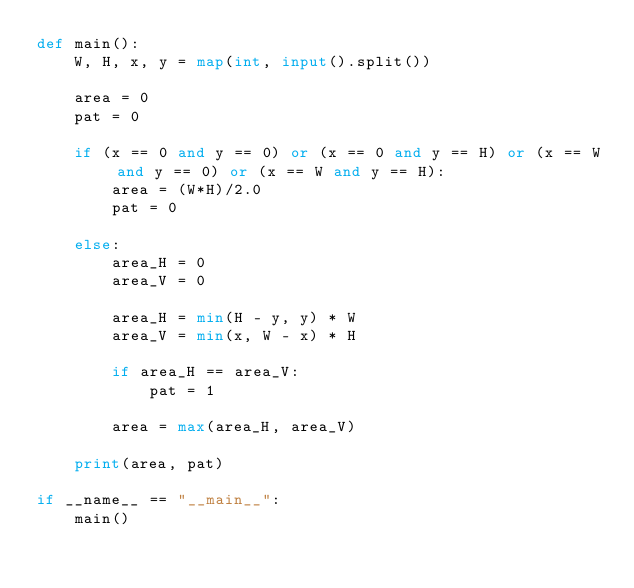Convert code to text. <code><loc_0><loc_0><loc_500><loc_500><_Python_>def main():
    W, H, x, y = map(int, input().split())

    area = 0
    pat = 0

    if (x == 0 and y == 0) or (x == 0 and y == H) or (x == W and y == 0) or (x == W and y == H):
        area = (W*H)/2.0
        pat = 0

    else:
        area_H = 0
        area_V = 0

        area_H = min(H - y, y) * W
        area_V = min(x, W - x) * H

        if area_H == area_V:
            pat = 1

        area = max(area_H, area_V)
        
    print(area, pat)

if __name__ == "__main__":
    main()</code> 